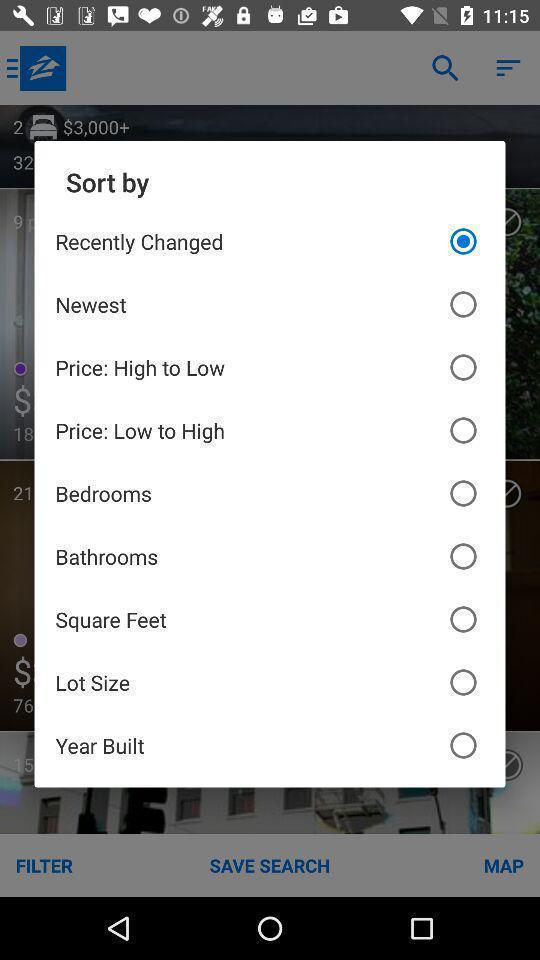Provide a detailed account of this screenshot. Pop-up shows to select an option. 